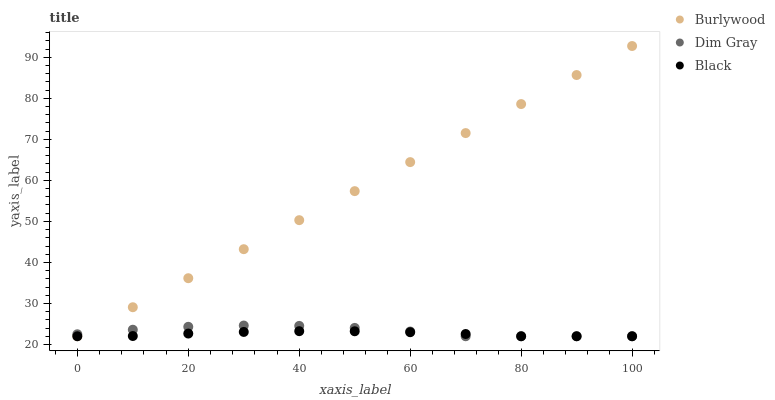Does Black have the minimum area under the curve?
Answer yes or no. Yes. Does Burlywood have the maximum area under the curve?
Answer yes or no. Yes. Does Dim Gray have the minimum area under the curve?
Answer yes or no. No. Does Dim Gray have the maximum area under the curve?
Answer yes or no. No. Is Burlywood the smoothest?
Answer yes or no. Yes. Is Dim Gray the roughest?
Answer yes or no. Yes. Is Black the smoothest?
Answer yes or no. No. Is Black the roughest?
Answer yes or no. No. Does Burlywood have the lowest value?
Answer yes or no. Yes. Does Burlywood have the highest value?
Answer yes or no. Yes. Does Dim Gray have the highest value?
Answer yes or no. No. Does Burlywood intersect Dim Gray?
Answer yes or no. Yes. Is Burlywood less than Dim Gray?
Answer yes or no. No. Is Burlywood greater than Dim Gray?
Answer yes or no. No. 